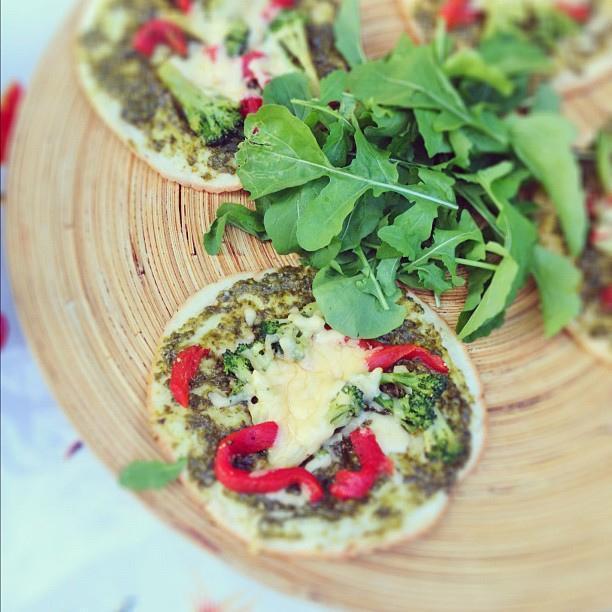How many broccolis are in the picture?
Give a very brief answer. 5. How many pizzas can be seen?
Give a very brief answer. 4. How many people can be seen?
Give a very brief answer. 0. 